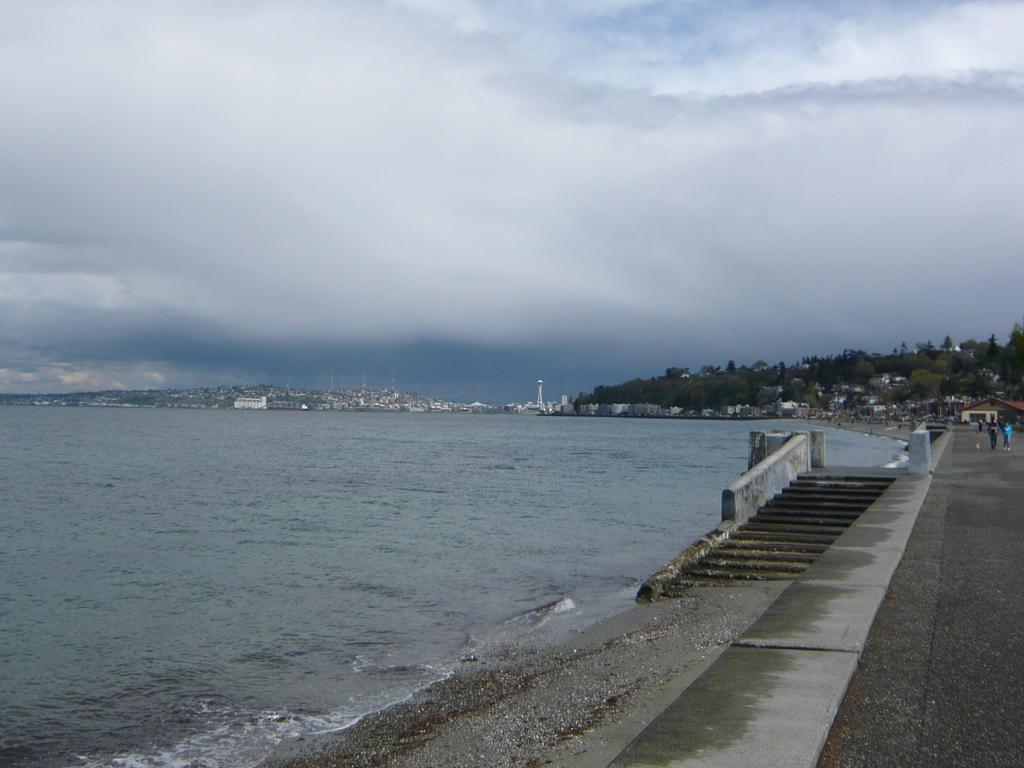What is located at the bottom of the image? There is a river and a walkway at the bottom of the image. What can be seen in the background of the image? There are buildings, trees, and some persons walking in the background of the image. What is visible at the top of the image? The sky is visible at the top of the image. Is there any waste visible in the image? There is no mention of waste in the provided facts, so we cannot determine if it is present in the image. What type of town is depicted in the image? The provided facts do not mention a town, so we cannot determine if it is depicted in the image. 